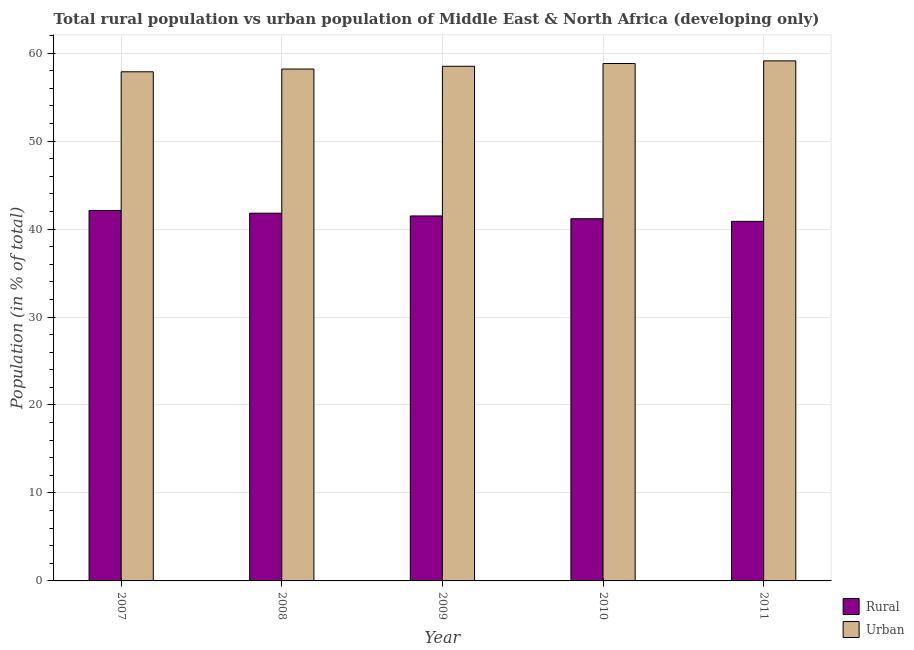How many different coloured bars are there?
Your answer should be very brief. 2. How many groups of bars are there?
Offer a very short reply. 5. Are the number of bars on each tick of the X-axis equal?
Offer a very short reply. Yes. In how many cases, is the number of bars for a given year not equal to the number of legend labels?
Keep it short and to the point. 0. What is the rural population in 2011?
Provide a succinct answer. 40.88. Across all years, what is the maximum urban population?
Ensure brevity in your answer.  59.12. Across all years, what is the minimum urban population?
Provide a succinct answer. 57.88. What is the total urban population in the graph?
Give a very brief answer. 292.53. What is the difference between the urban population in 2007 and that in 2008?
Offer a very short reply. -0.31. What is the difference between the urban population in 2008 and the rural population in 2007?
Offer a very short reply. 0.31. What is the average urban population per year?
Give a very brief answer. 58.51. What is the ratio of the urban population in 2007 to that in 2011?
Keep it short and to the point. 0.98. What is the difference between the highest and the second highest urban population?
Offer a terse response. 0.3. What is the difference between the highest and the lowest rural population?
Provide a succinct answer. 1.24. What does the 2nd bar from the left in 2011 represents?
Give a very brief answer. Urban. What does the 1st bar from the right in 2007 represents?
Provide a succinct answer. Urban. Are all the bars in the graph horizontal?
Offer a very short reply. No. How many years are there in the graph?
Your answer should be very brief. 5. Are the values on the major ticks of Y-axis written in scientific E-notation?
Your response must be concise. No. Does the graph contain grids?
Make the answer very short. Yes. Where does the legend appear in the graph?
Offer a very short reply. Bottom right. How are the legend labels stacked?
Make the answer very short. Vertical. What is the title of the graph?
Ensure brevity in your answer.  Total rural population vs urban population of Middle East & North Africa (developing only). What is the label or title of the X-axis?
Your response must be concise. Year. What is the label or title of the Y-axis?
Ensure brevity in your answer.  Population (in % of total). What is the Population (in % of total) in Rural in 2007?
Keep it short and to the point. 42.12. What is the Population (in % of total) of Urban in 2007?
Your answer should be compact. 57.88. What is the Population (in % of total) of Rural in 2008?
Offer a terse response. 41.81. What is the Population (in % of total) in Urban in 2008?
Give a very brief answer. 58.19. What is the Population (in % of total) in Rural in 2009?
Ensure brevity in your answer.  41.49. What is the Population (in % of total) of Urban in 2009?
Offer a very short reply. 58.51. What is the Population (in % of total) of Rural in 2010?
Your answer should be very brief. 41.18. What is the Population (in % of total) of Urban in 2010?
Your response must be concise. 58.82. What is the Population (in % of total) in Rural in 2011?
Provide a short and direct response. 40.88. What is the Population (in % of total) in Urban in 2011?
Offer a very short reply. 59.12. Across all years, what is the maximum Population (in % of total) in Rural?
Offer a very short reply. 42.12. Across all years, what is the maximum Population (in % of total) in Urban?
Provide a succinct answer. 59.12. Across all years, what is the minimum Population (in % of total) in Rural?
Offer a terse response. 40.88. Across all years, what is the minimum Population (in % of total) of Urban?
Keep it short and to the point. 57.88. What is the total Population (in % of total) in Rural in the graph?
Keep it short and to the point. 207.47. What is the total Population (in % of total) of Urban in the graph?
Provide a succinct answer. 292.53. What is the difference between the Population (in % of total) of Rural in 2007 and that in 2008?
Make the answer very short. 0.31. What is the difference between the Population (in % of total) in Urban in 2007 and that in 2008?
Provide a succinct answer. -0.31. What is the difference between the Population (in % of total) of Rural in 2007 and that in 2009?
Your response must be concise. 0.62. What is the difference between the Population (in % of total) in Urban in 2007 and that in 2009?
Your answer should be very brief. -0.62. What is the difference between the Population (in % of total) of Rural in 2007 and that in 2010?
Provide a succinct answer. 0.94. What is the difference between the Population (in % of total) of Urban in 2007 and that in 2010?
Offer a terse response. -0.94. What is the difference between the Population (in % of total) of Rural in 2007 and that in 2011?
Give a very brief answer. 1.24. What is the difference between the Population (in % of total) in Urban in 2007 and that in 2011?
Your answer should be compact. -1.24. What is the difference between the Population (in % of total) in Rural in 2008 and that in 2009?
Provide a succinct answer. 0.31. What is the difference between the Population (in % of total) in Urban in 2008 and that in 2009?
Offer a terse response. -0.31. What is the difference between the Population (in % of total) in Rural in 2008 and that in 2010?
Keep it short and to the point. 0.63. What is the difference between the Population (in % of total) of Urban in 2008 and that in 2010?
Your answer should be compact. -0.63. What is the difference between the Population (in % of total) in Rural in 2008 and that in 2011?
Your answer should be very brief. 0.93. What is the difference between the Population (in % of total) of Urban in 2008 and that in 2011?
Make the answer very short. -0.93. What is the difference between the Population (in % of total) in Rural in 2009 and that in 2010?
Your response must be concise. 0.32. What is the difference between the Population (in % of total) of Urban in 2009 and that in 2010?
Your answer should be very brief. -0.32. What is the difference between the Population (in % of total) of Rural in 2009 and that in 2011?
Your answer should be very brief. 0.62. What is the difference between the Population (in % of total) in Urban in 2009 and that in 2011?
Ensure brevity in your answer.  -0.62. What is the difference between the Population (in % of total) in Rural in 2010 and that in 2011?
Give a very brief answer. 0.3. What is the difference between the Population (in % of total) of Urban in 2010 and that in 2011?
Provide a succinct answer. -0.3. What is the difference between the Population (in % of total) in Rural in 2007 and the Population (in % of total) in Urban in 2008?
Keep it short and to the point. -16.08. What is the difference between the Population (in % of total) of Rural in 2007 and the Population (in % of total) of Urban in 2009?
Offer a terse response. -16.39. What is the difference between the Population (in % of total) of Rural in 2007 and the Population (in % of total) of Urban in 2010?
Ensure brevity in your answer.  -16.71. What is the difference between the Population (in % of total) of Rural in 2007 and the Population (in % of total) of Urban in 2011?
Keep it short and to the point. -17. What is the difference between the Population (in % of total) of Rural in 2008 and the Population (in % of total) of Urban in 2009?
Keep it short and to the point. -16.7. What is the difference between the Population (in % of total) in Rural in 2008 and the Population (in % of total) in Urban in 2010?
Give a very brief answer. -17.02. What is the difference between the Population (in % of total) of Rural in 2008 and the Population (in % of total) of Urban in 2011?
Give a very brief answer. -17.32. What is the difference between the Population (in % of total) of Rural in 2009 and the Population (in % of total) of Urban in 2010?
Provide a short and direct response. -17.33. What is the difference between the Population (in % of total) of Rural in 2009 and the Population (in % of total) of Urban in 2011?
Your answer should be compact. -17.63. What is the difference between the Population (in % of total) of Rural in 2010 and the Population (in % of total) of Urban in 2011?
Your response must be concise. -17.95. What is the average Population (in % of total) of Rural per year?
Provide a short and direct response. 41.49. What is the average Population (in % of total) in Urban per year?
Provide a succinct answer. 58.51. In the year 2007, what is the difference between the Population (in % of total) of Rural and Population (in % of total) of Urban?
Provide a succinct answer. -15.77. In the year 2008, what is the difference between the Population (in % of total) of Rural and Population (in % of total) of Urban?
Keep it short and to the point. -16.39. In the year 2009, what is the difference between the Population (in % of total) of Rural and Population (in % of total) of Urban?
Provide a short and direct response. -17.01. In the year 2010, what is the difference between the Population (in % of total) in Rural and Population (in % of total) in Urban?
Offer a terse response. -17.65. In the year 2011, what is the difference between the Population (in % of total) of Rural and Population (in % of total) of Urban?
Provide a succinct answer. -18.24. What is the ratio of the Population (in % of total) of Rural in 2007 to that in 2008?
Make the answer very short. 1.01. What is the ratio of the Population (in % of total) of Urban in 2007 to that in 2008?
Make the answer very short. 0.99. What is the ratio of the Population (in % of total) of Rural in 2007 to that in 2009?
Keep it short and to the point. 1.01. What is the ratio of the Population (in % of total) of Urban in 2007 to that in 2009?
Your answer should be very brief. 0.99. What is the ratio of the Population (in % of total) in Rural in 2007 to that in 2010?
Make the answer very short. 1.02. What is the ratio of the Population (in % of total) in Urban in 2007 to that in 2010?
Offer a very short reply. 0.98. What is the ratio of the Population (in % of total) in Rural in 2007 to that in 2011?
Provide a short and direct response. 1.03. What is the ratio of the Population (in % of total) of Urban in 2007 to that in 2011?
Make the answer very short. 0.98. What is the ratio of the Population (in % of total) of Rural in 2008 to that in 2009?
Make the answer very short. 1.01. What is the ratio of the Population (in % of total) of Rural in 2008 to that in 2010?
Provide a short and direct response. 1.02. What is the ratio of the Population (in % of total) of Urban in 2008 to that in 2010?
Make the answer very short. 0.99. What is the ratio of the Population (in % of total) of Rural in 2008 to that in 2011?
Your answer should be very brief. 1.02. What is the ratio of the Population (in % of total) in Urban in 2008 to that in 2011?
Your answer should be compact. 0.98. What is the ratio of the Population (in % of total) in Rural in 2009 to that in 2010?
Offer a very short reply. 1.01. What is the ratio of the Population (in % of total) in Rural in 2009 to that in 2011?
Your answer should be very brief. 1.02. What is the ratio of the Population (in % of total) in Urban in 2009 to that in 2011?
Your response must be concise. 0.99. What is the ratio of the Population (in % of total) of Rural in 2010 to that in 2011?
Offer a terse response. 1.01. What is the ratio of the Population (in % of total) of Urban in 2010 to that in 2011?
Provide a short and direct response. 0.99. What is the difference between the highest and the second highest Population (in % of total) in Rural?
Ensure brevity in your answer.  0.31. What is the difference between the highest and the second highest Population (in % of total) of Urban?
Ensure brevity in your answer.  0.3. What is the difference between the highest and the lowest Population (in % of total) in Rural?
Give a very brief answer. 1.24. What is the difference between the highest and the lowest Population (in % of total) in Urban?
Your answer should be very brief. 1.24. 